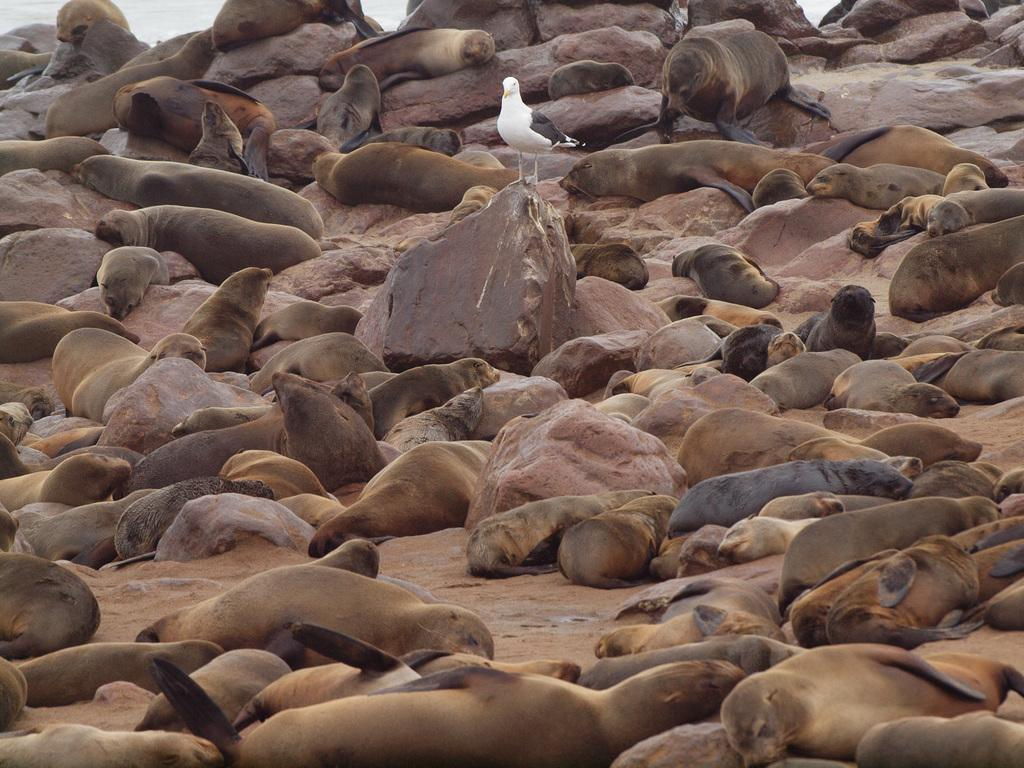What type of natural formation can be seen in the image? There are rocks in the image. What animals are present in the image? There are seals in the image. Can you describe the location of the rock in the middle of the image? There is a rock in the middle of the image. What is above the rock in the middle of the image? There is a bird above the rock in the middle of the image. What type of leather is being used to make the seals' coats in the image? There is no leather present in the image, as seals have fur, not leather, coats. 